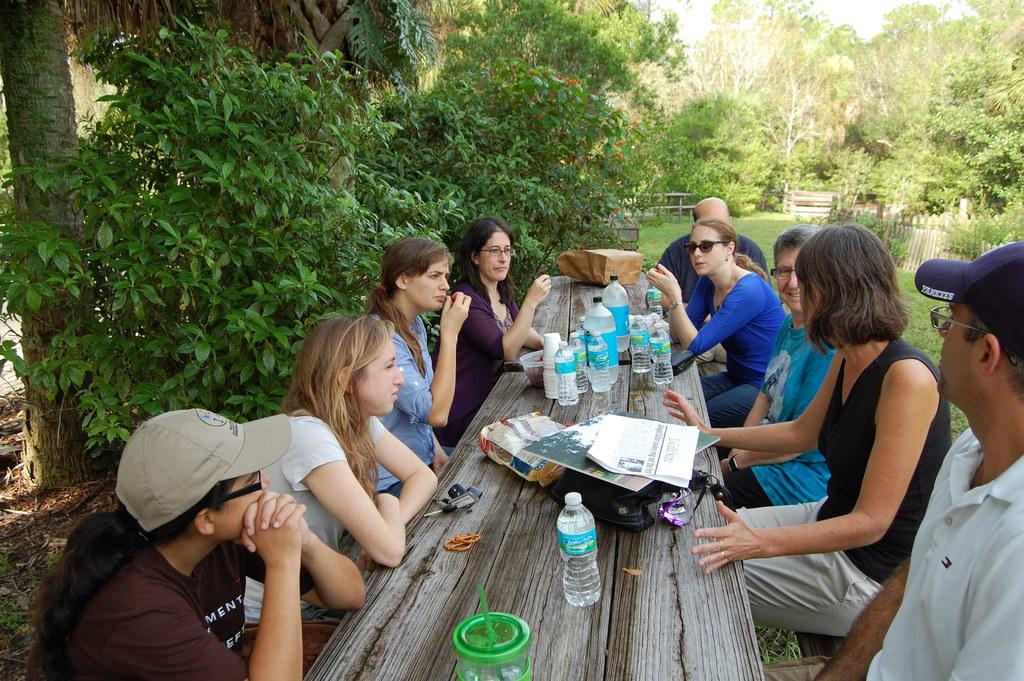How many people are in the image? There is a group of people in the image. What are the people doing in the image? The people are seated on a bench. What items can be seen on the bench with the people? There are water bottles and papers on the bench. What can be seen in the background of the image? There are trees visible around the bench. What type of soap is being used by the people in the image? There is no soap present in the image; the people are seated on a bench with water bottles and papers. 